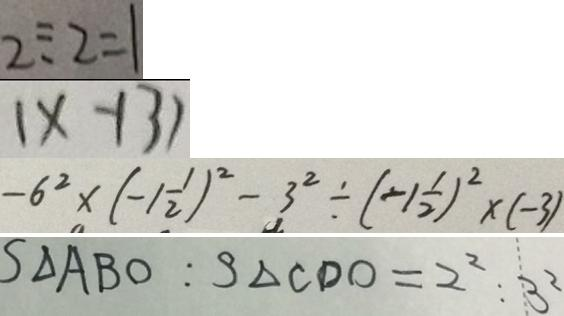<formula> <loc_0><loc_0><loc_500><loc_500>2 \div 2 = 1 
 ( x - 1 3 ) 
 - 6 ^ { 2 } \times ( - 1 \frac { 1 } { 2 } ) ^ { 2 } - 3 ^ { 2 } \div ( - 1 \frac { 1 } { 2 } ) ^ { 2 } \times ( - 3 ) 
 S _ { \Delta } A B O : S _ { \Delta } C D O = 2 ^ { 2 } : 3 ^ { 2 }</formula> 